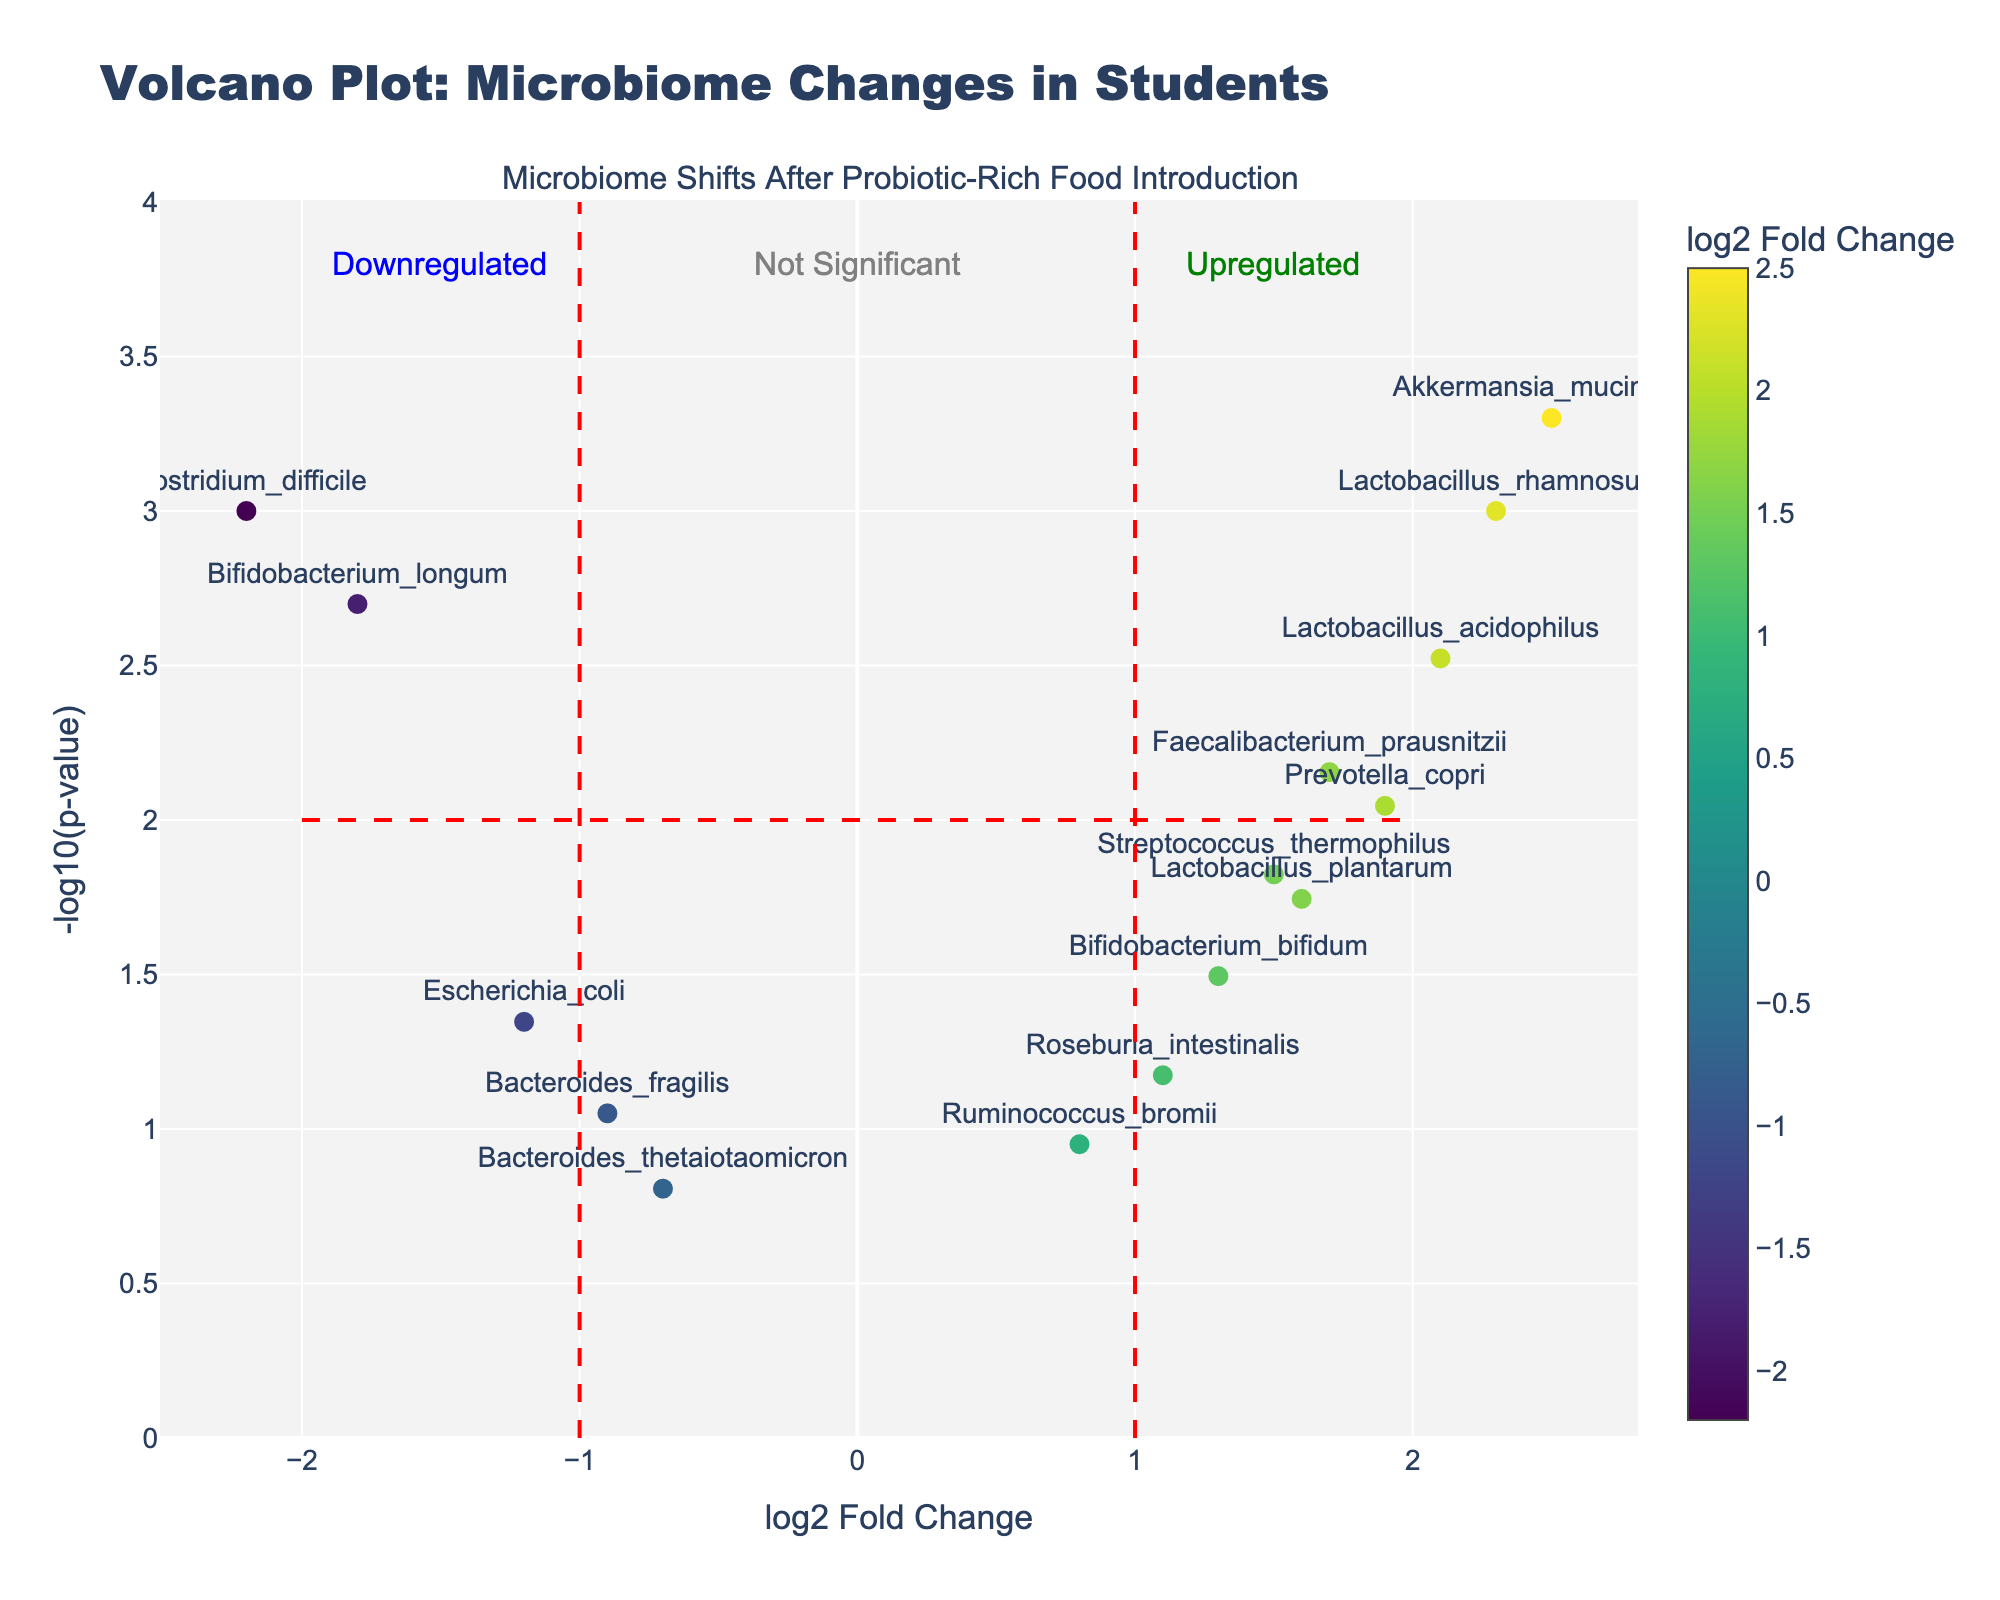What is the title of the plot? The title is typically written at the top of the figure and describes what the plot is about. In this case, it says "Volcano Plot: Microbiome Changes in Students."
Answer: Volcano Plot: Microbiome Changes in Students What do the x-axis and y-axis represent in this plot? The x-axis and y-axis labels describe the variables being plotted. The x-axis represents 'log2 Fold Change,' and the y-axis represents '-log10(p-value).'
Answer: The x-axis represents 'log2 Fold Change,' and the y-axis represents '-log10(p-value).' Which bacterium has the highest log2 fold change? By looking at the x-axis values, we can see which bacterium is furthest to the right on the plot, indicating the highest log2 fold change. In this case, it is 'Akkermansia_muciniphila' with a log2 fold change of 2.5.
Answer: Akkermansia_muciniphila How many bacteria are significantly upregulated (log2 fold change > 1 and -log10(p-value) > 2)? Bacteria that are significantly upregulated will be to the right of the vertical threshold line at log2 fold change = 1 and above the horizontal threshold line at -log10(p-value) = 2. These points are visually identified as 'Lactobacillus_rhamnosus,' 'Lactobacillus_acidophilus,' and 'Akkermansia_muciniphila.'
Answer: Three bacteria Which bacterial species is the most significantly downregulated? The most significantly downregulated bacterium will be the one with the lowest log2 fold change value (furthest to the left) and the highest -log10(p-value) value. 'Clostridium_difficile' is the furthest to the left and above the horizontal threshold.
Answer: Clostridium_difficile What can be inferred about Bacteroides_thetaiotaomicron based on its position on the plot? The bacterium 'Bacteroides_thetaiotaomicron' is positioned at a log2 fold change of -0.7 and a -log10(p-value) of 0.156. It is neither far to the left/right nor significantly above the threshold line, indicating that it is not significantly affected.
Answer: Not significantly affected Which bacterial species has a p-value closest to 0.045? A p-value closest to 0.045 translates visually to a -log10(p-value) around 1.35. Looking at the plot, 'Escherichia_coli' fits this description with a -log10(p-value) corresponding to around this value.
Answer: Escherichia_coli Compare Lactobacillus_plantarum and Bifidobacterium_bifidum. Which one shows a greater fold change? To compare their fold changes, we look at the log2 fold change values for both species. 'Lactobacillus_plantarum' has a log2 fold change of 1.6, whereas 'Bifidobacterium_bifidum' has a log2 fold change of 1.3. Thus, 'Lactobacillus_plantarum' shows a greater fold change.
Answer: Lactobacillus_plantarum What's the significance cutoff for p-value indicated by the horizontal threshold line? The position of the horizontal threshold line represents a significance cutoff for -log10(p-value). The line is at y=2, which corresponds to a p-value cutoff of 10^-2 or 0.01.
Answer: 0.01 